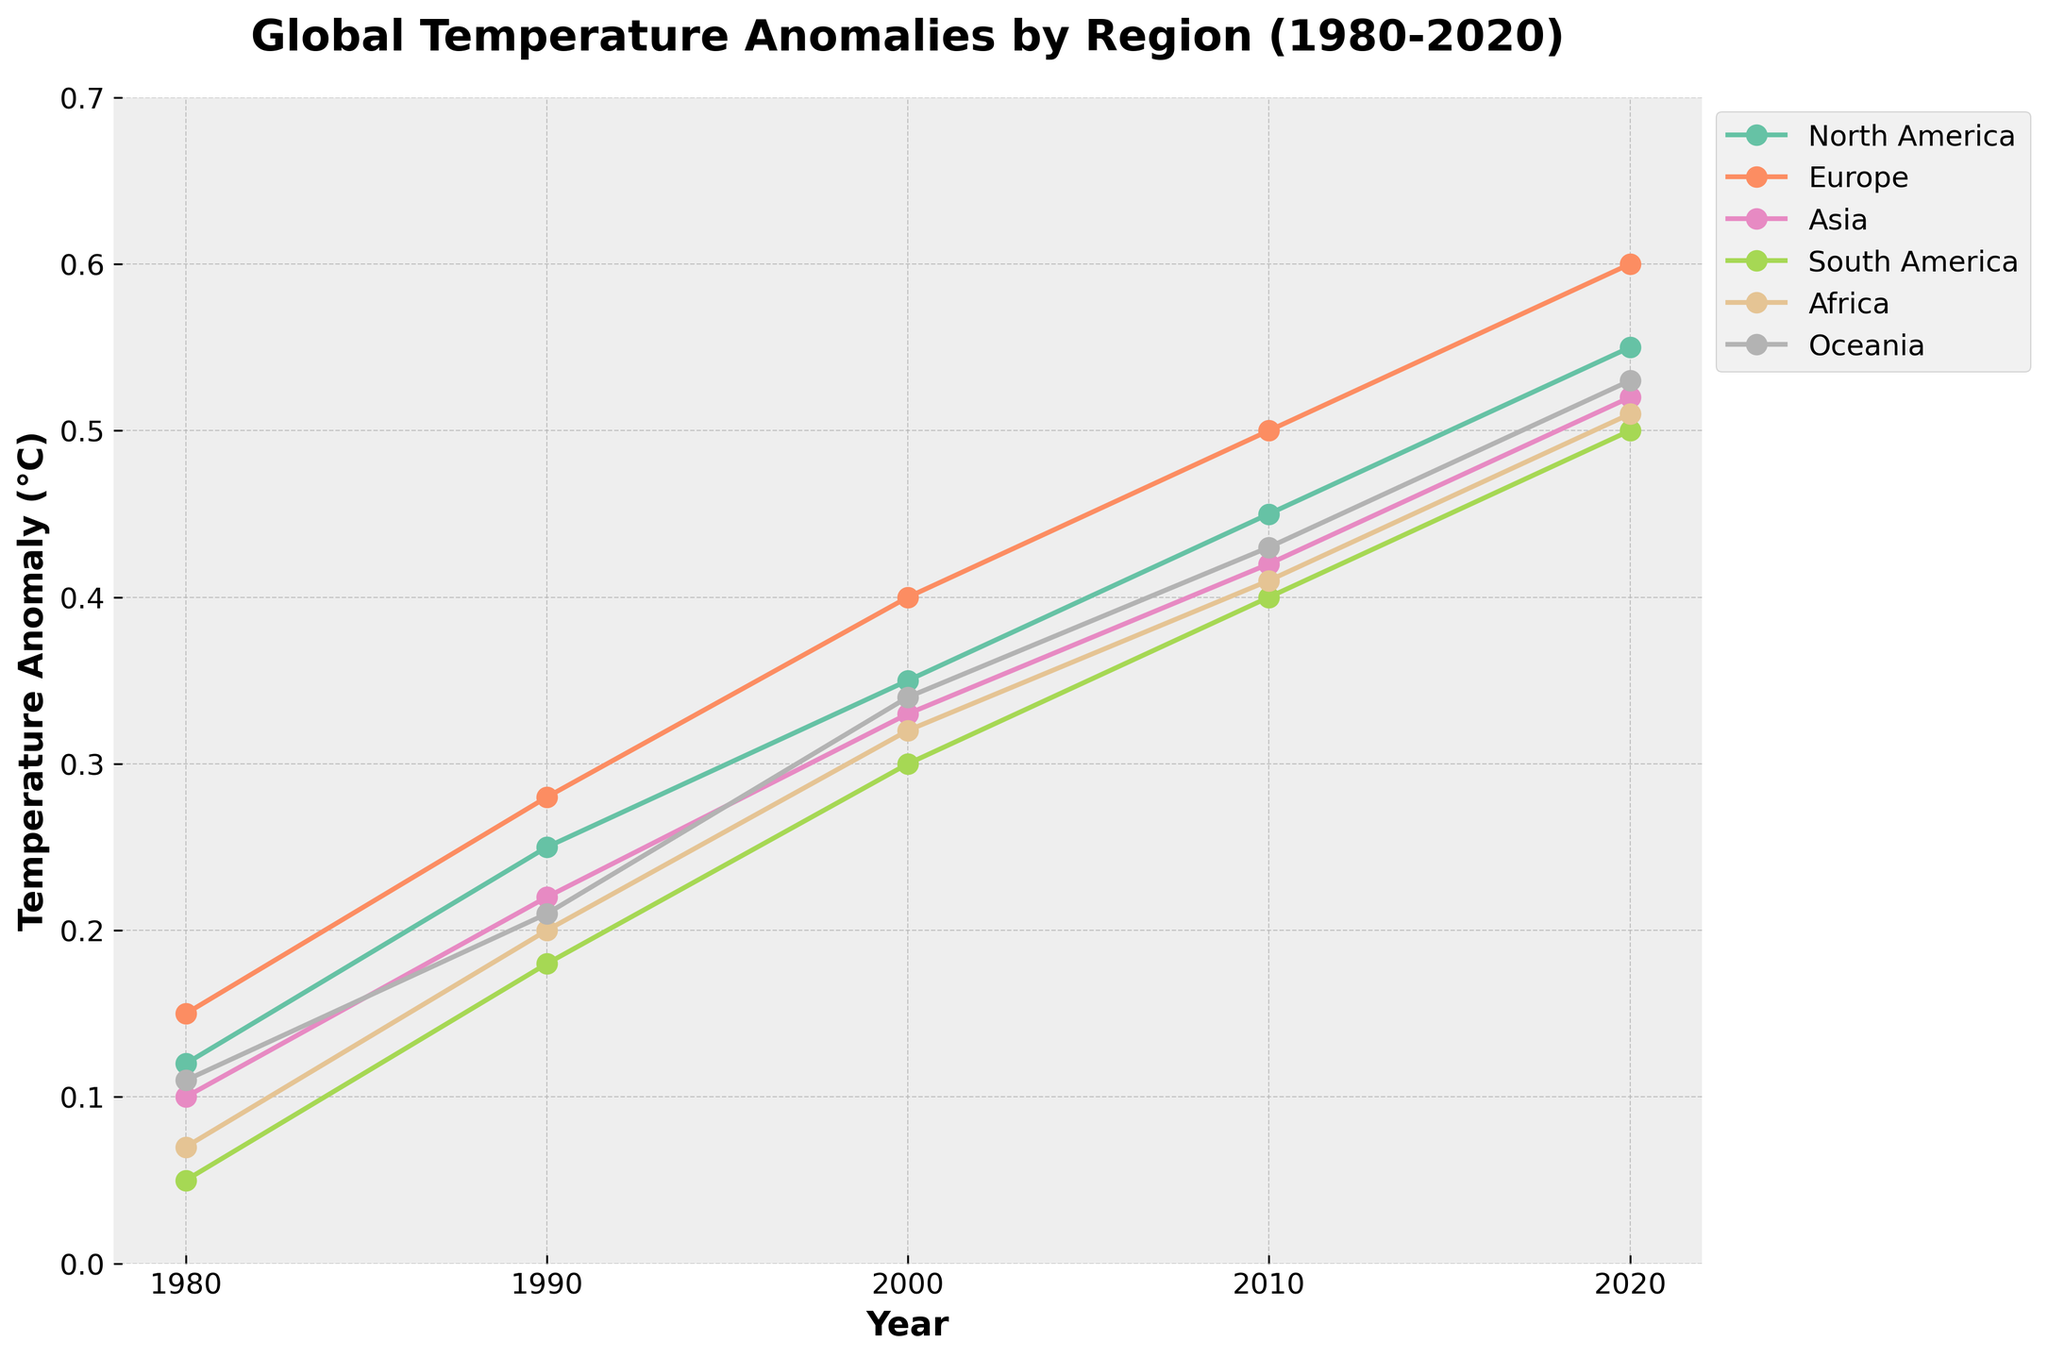What is the title of the plot? The title is prominently displayed at the top of the figure, depicting the main topic of the graph.
Answer: Global Temperature Anomalies by Region (1980-2020) Which region shows the highest temperature anomaly in 2020? The highest point on the plot in 2020 can be identified by examining the endpoint of each regional line.
Answer: Europe What is the range of the y-axis in the plot? The y-axis range can be determined by examining the numerical values beside the y-axis.
Answer: 0 to 0.7 Compare the temperature anomalies of North America and Asia in 2000. Which region had a higher anomaly? The data points for both regions in 2000 can be compared on the y-axis.
Answer: North America How much did the temperature anomaly increase in Europe from 1990 to 2020? Subtract the temperature anomaly value for Europe in 1990 from the value in 2020 (0.60 - 0.28).
Answer: 0.32°C What's the average temperature anomaly for Africa between 1980 and 2020? To find the average, sum the temperature anomalies for Africa across all five decades and divide by the number of data points (0.07 + 0.20 + 0.32 + 0.41 + 0.51) / 5.
Answer: 0.302°C Which region had the smallest temperature anomaly increase from 1980 to 2020? Calculate the difference in temperature anomaly for each region from 1980 to 2020, then compare the results. (North America: 0.55 - 0.12 = 0.43, Europe: 0.60 - 0.15 = 0.45, Asia: 0.52 - 0.10 = 0.42, South America: 0.50 - 0.05 = 0.45, Africa: 0.51 - 0.07 = 0.44, Oceania: 0.53 - 0.11 = 0.42).
Answer: Asia and Oceania (both 0.42) What is the trend of temperature anomalies for South America from 1980 to 2020? The plot line for South America shows a consistent upward trend when observed across the years 1980 to 2020.
Answer: Increasing Identify the year when Europe experienced the largest temperature anomaly. The highest y-axis value for Europe can be found by tracing the plot line or checking which year corresponds to the peak value.
Answer: 2020 During which decade did Oceania experience the smallest increase in temperature anomaly? Calculate the temperature anomaly differences between each consecutive decade for Oceania and identify the smallest difference (1990: 0.21 - 1980: 0.11 = 0.10, 2000: 0.34 - 1990: 0.21 = 0.13, 2010: 0.43 - 2000: 0.34 = 0.09, 2020: 0.53 - 2010: 0.43 = 0.10).
Answer: 2000 to 2010 Is there any period where the global temperature anomalies decrease in any of the regions? Observe all the plot lines for any downward trend in anomaly values within the time range.
Answer: No 